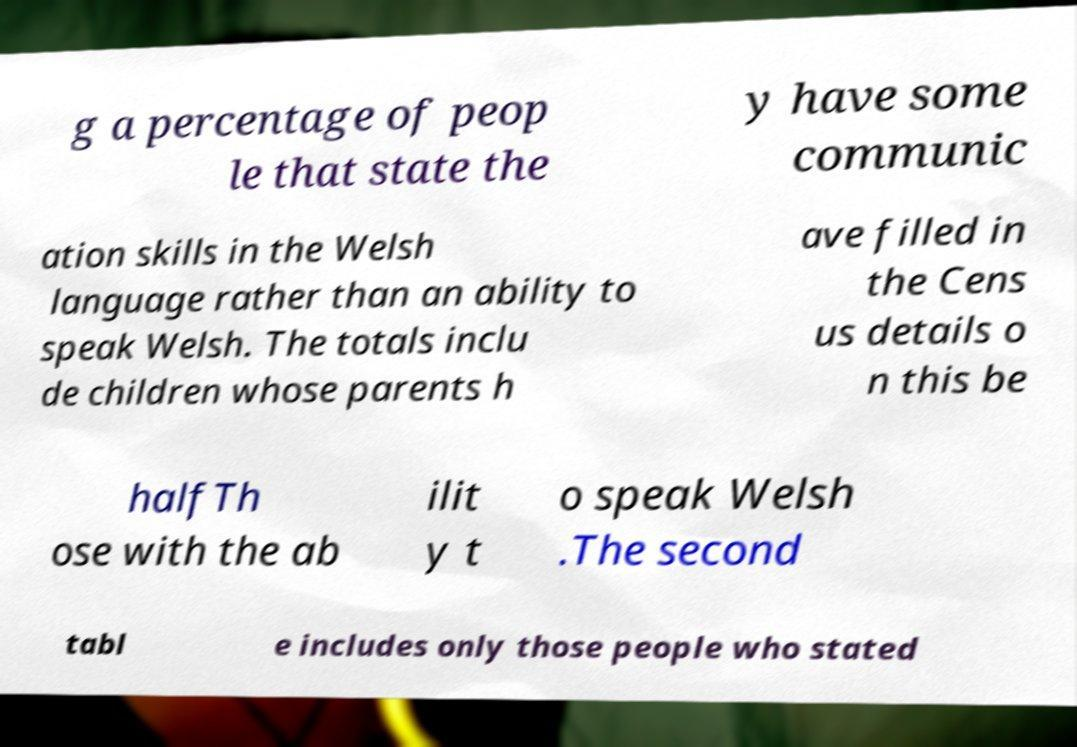Please identify and transcribe the text found in this image. g a percentage of peop le that state the y have some communic ation skills in the Welsh language rather than an ability to speak Welsh. The totals inclu de children whose parents h ave filled in the Cens us details o n this be halfTh ose with the ab ilit y t o speak Welsh .The second tabl e includes only those people who stated 